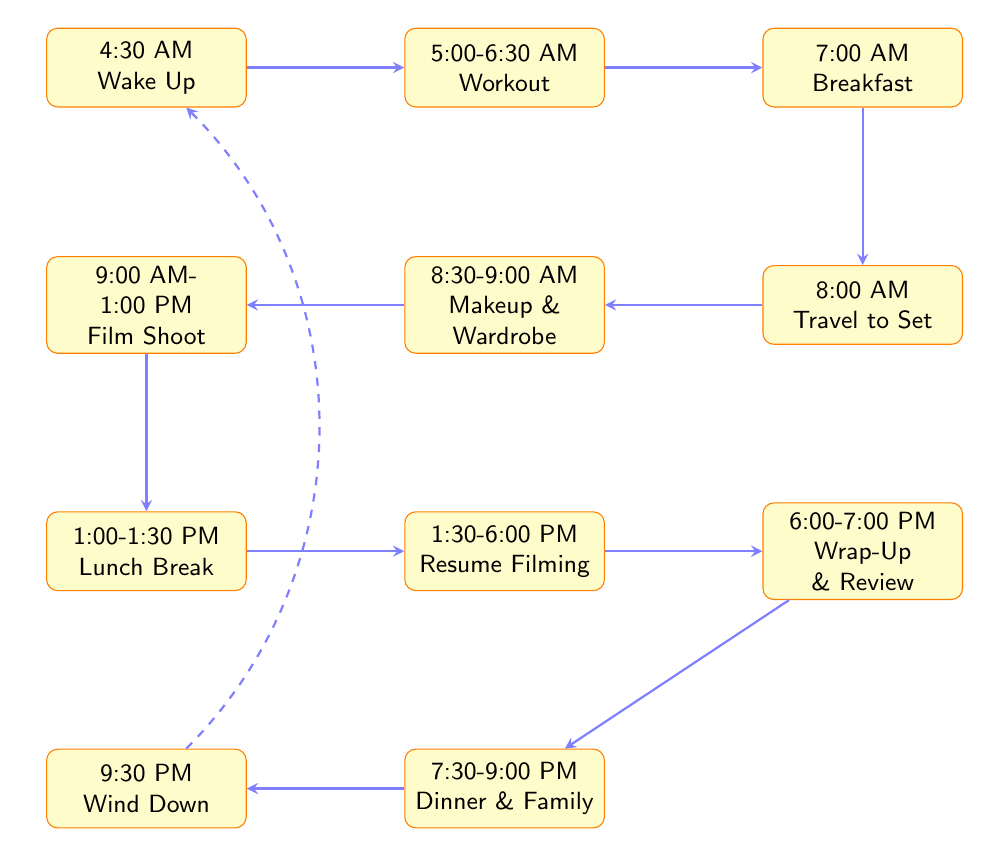What time does Dwayne Johnson wake up? The diagram shows the first node labeled "Wake Up," which indicates that he wakes up at 4:30 AM.
Answer: 4:30 AM What activity takes place right after breakfast? According to the flow chart, after the "Breakfast" node, the next activity is "Travel to Film Set."
Answer: Travel to Film Set How long does the workout session last? The "Workout" node states that it lasts from 5:00 AM to 6:30 AM, which is a duration of 1.5 hours, or 90 minutes.
Answer: 1.5 hours What follows the Lunch Break in the daily schedule? From the diagram, after the "Lunch Break" node, the next activity is "Resume Filming."
Answer: Resume Filming How many main activities are listed in the diagram? By counting all the distinct nodes in the diagram, there are 11 main activities noted.
Answer: 11 What time does filming start? The "Film Shoot" node specifies that filming starts at 9:00 AM.
Answer: 9:00 AM What does Dwayne Johnson do after wrapping up filming? The sequence shows that the "Wrap-Up and Review" activity directly follows the filming sessions.
Answer: Wrap-Up and Review At what time does he have family time? The diagram indicates that "Dinner and Family Time" starts at 7:30 PM.
Answer: 7:30 PM How does Dwayne Johnson wind down his day? The final node describes "Wind Down," which is listed as the last activity of the day at 9:30 PM.
Answer: Wind Down 